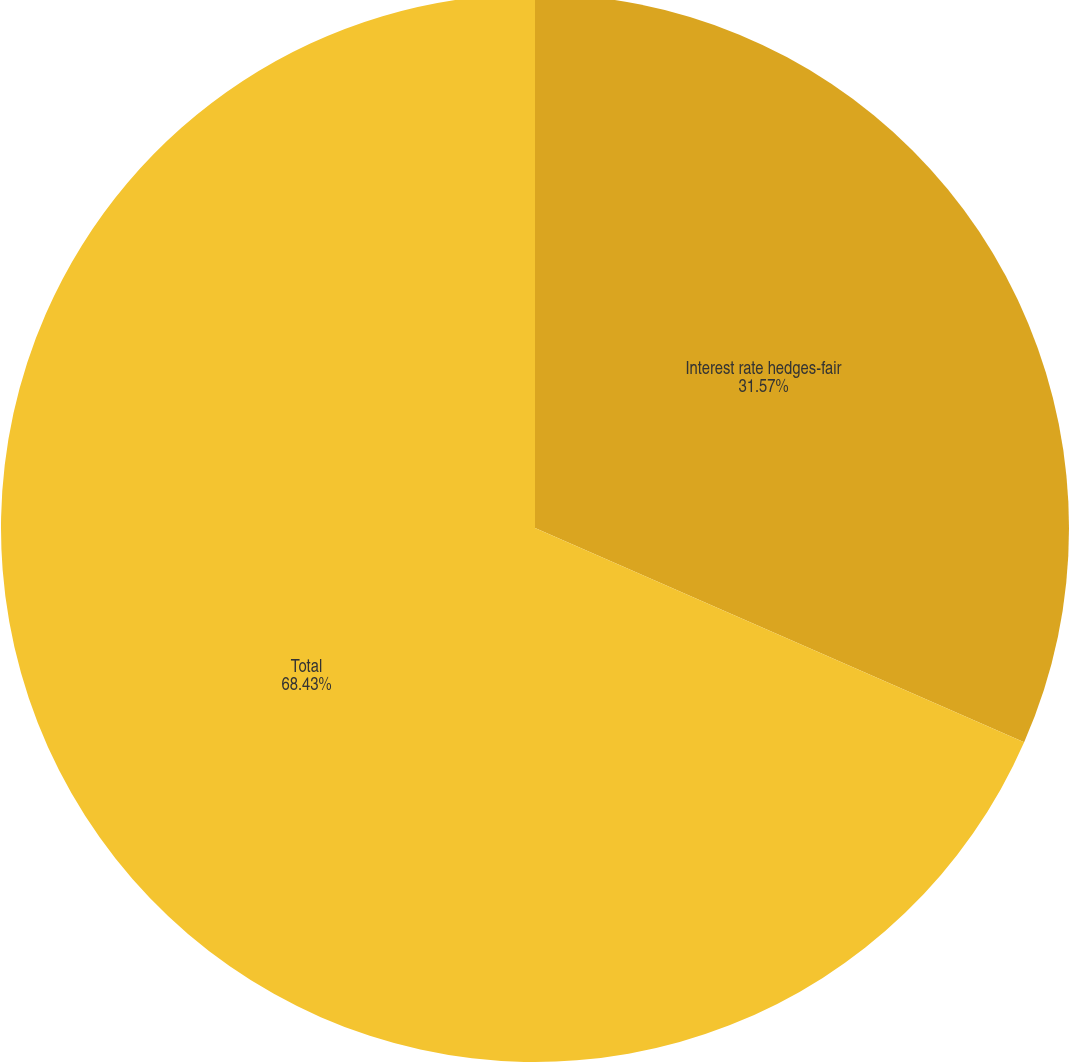Convert chart to OTSL. <chart><loc_0><loc_0><loc_500><loc_500><pie_chart><fcel>Interest rate hedges-fair<fcel>Total<nl><fcel>31.57%<fcel>68.43%<nl></chart> 